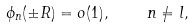<formula> <loc_0><loc_0><loc_500><loc_500>\phi _ { n } ( \pm R ) = o ( 1 ) , \quad n \neq l ,</formula> 